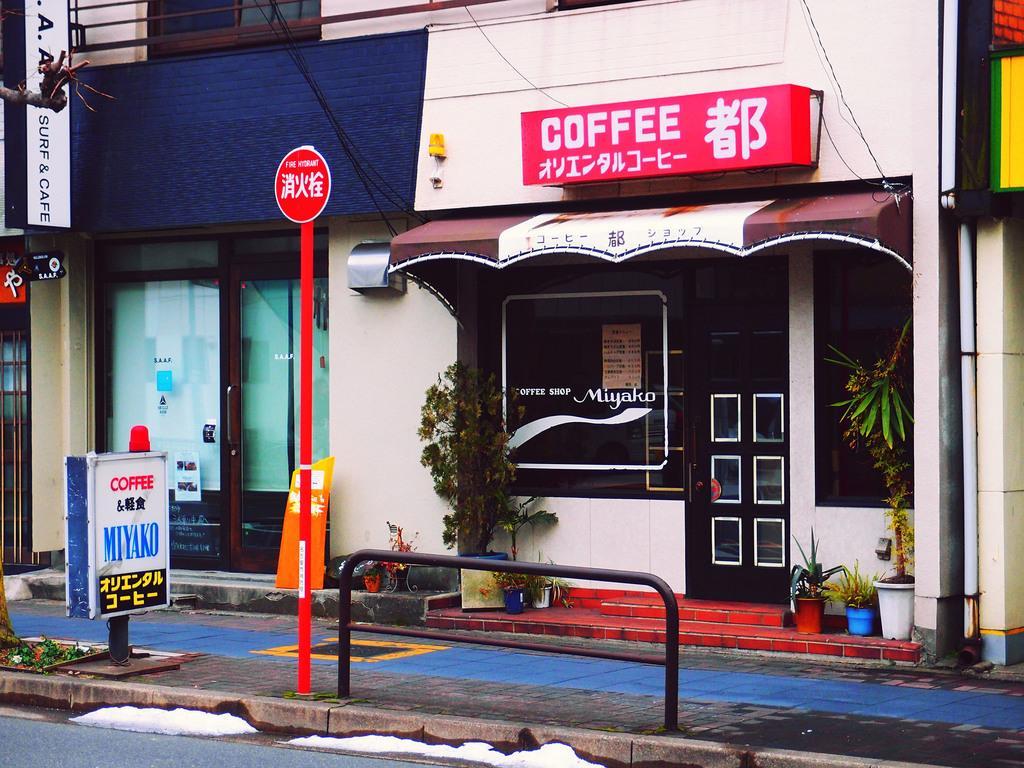Describe this image in one or two sentences. In this picture we can see a building, there are some hoardings here, we can see a pole and a board in the front, on the right side there is a store, we can see plants and a door, we can see glass here. 